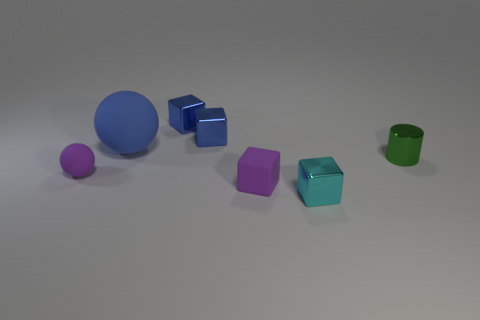Subtract all green blocks. Subtract all green spheres. How many blocks are left? 4 Add 2 big objects. How many objects exist? 9 Subtract all balls. How many objects are left? 5 Add 4 small blue objects. How many small blue objects are left? 6 Add 2 small gray metal cubes. How many small gray metal cubes exist? 2 Subtract 0 brown cylinders. How many objects are left? 7 Subtract all big spheres. Subtract all purple blocks. How many objects are left? 5 